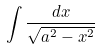Convert formula to latex. <formula><loc_0><loc_0><loc_500><loc_500>\int \frac { d x } { \sqrt { a ^ { 2 } - x ^ { 2 } } }</formula> 